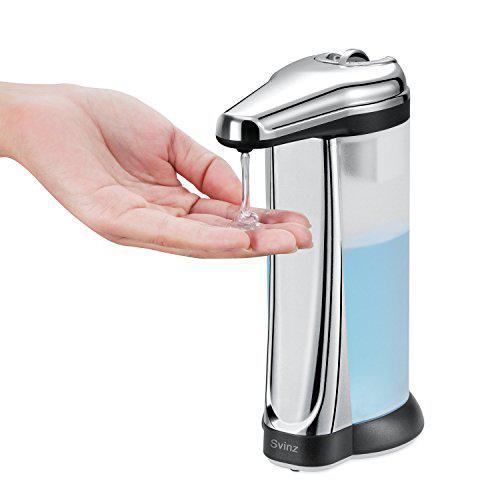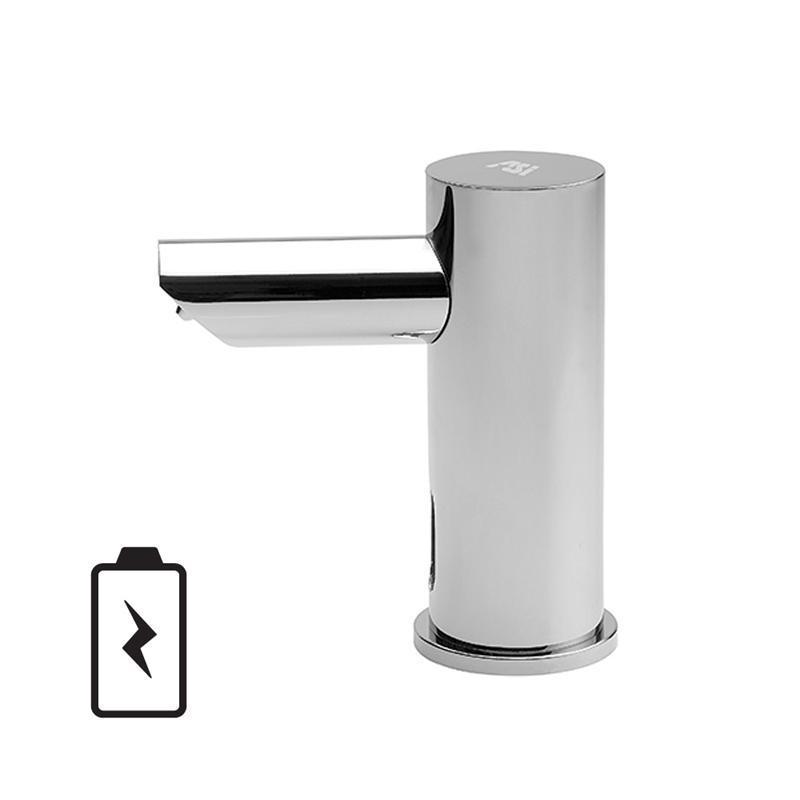The first image is the image on the left, the second image is the image on the right. For the images displayed, is the sentence "One image has no hands." factually correct? Answer yes or no. Yes. The first image is the image on the left, the second image is the image on the right. Considering the images on both sides, is "There is a hand in the image on the right" valid? Answer yes or no. No. 